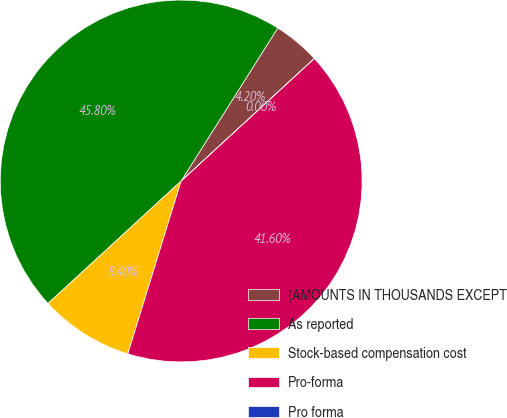Convert chart to OTSL. <chart><loc_0><loc_0><loc_500><loc_500><pie_chart><fcel>(AMOUNTS IN THOUSANDS EXCEPT<fcel>As reported<fcel>Stock-based compensation cost<fcel>Pro-forma<fcel>Pro forma<nl><fcel>4.2%<fcel>45.8%<fcel>8.4%<fcel>41.6%<fcel>0.0%<nl></chart> 